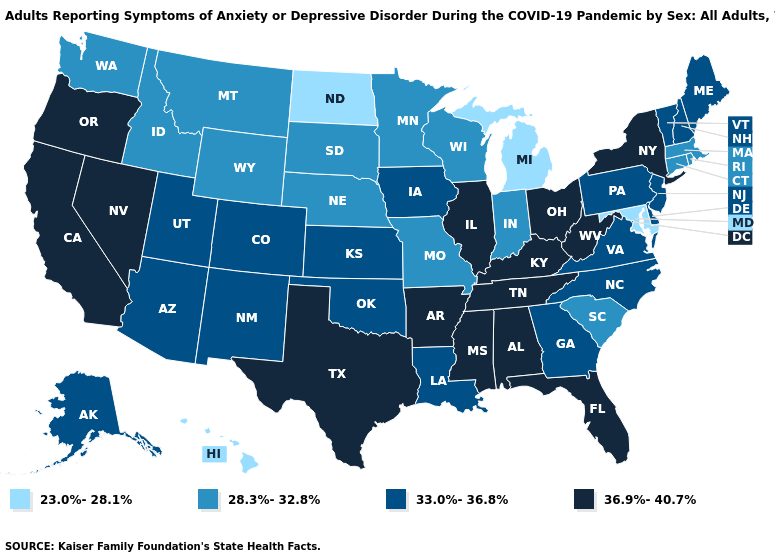What is the value of Michigan?
Quick response, please. 23.0%-28.1%. Which states have the lowest value in the USA?
Keep it brief. Hawaii, Maryland, Michigan, North Dakota. Name the states that have a value in the range 23.0%-28.1%?
Write a very short answer. Hawaii, Maryland, Michigan, North Dakota. What is the highest value in the South ?
Be succinct. 36.9%-40.7%. Among the states that border Kentucky , which have the highest value?
Short answer required. Illinois, Ohio, Tennessee, West Virginia. What is the value of West Virginia?
Short answer required. 36.9%-40.7%. Among the states that border Maryland , which have the highest value?
Quick response, please. West Virginia. What is the value of Texas?
Answer briefly. 36.9%-40.7%. Among the states that border Connecticut , does New York have the highest value?
Write a very short answer. Yes. Among the states that border New York , does Connecticut have the highest value?
Write a very short answer. No. Name the states that have a value in the range 28.3%-32.8%?
Answer briefly. Connecticut, Idaho, Indiana, Massachusetts, Minnesota, Missouri, Montana, Nebraska, Rhode Island, South Carolina, South Dakota, Washington, Wisconsin, Wyoming. Does Nebraska have the lowest value in the MidWest?
Answer briefly. No. Does the first symbol in the legend represent the smallest category?
Answer briefly. Yes. Name the states that have a value in the range 28.3%-32.8%?
Be succinct. Connecticut, Idaho, Indiana, Massachusetts, Minnesota, Missouri, Montana, Nebraska, Rhode Island, South Carolina, South Dakota, Washington, Wisconsin, Wyoming. Name the states that have a value in the range 23.0%-28.1%?
Be succinct. Hawaii, Maryland, Michigan, North Dakota. 